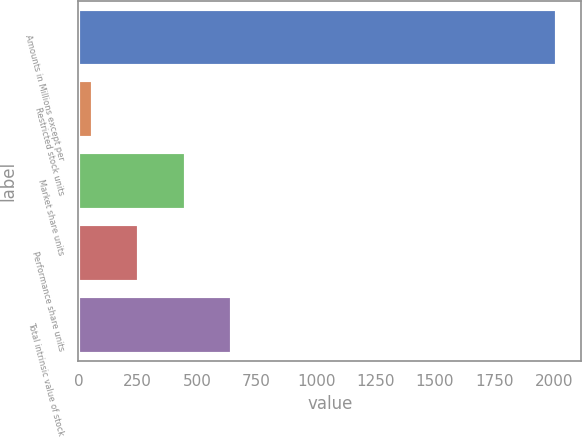<chart> <loc_0><loc_0><loc_500><loc_500><bar_chart><fcel>Amounts in Millions except per<fcel>Restricted stock units<fcel>Market share units<fcel>Performance share units<fcel>Total intrinsic value of stock<nl><fcel>2015<fcel>61.18<fcel>451.94<fcel>256.56<fcel>647.32<nl></chart> 